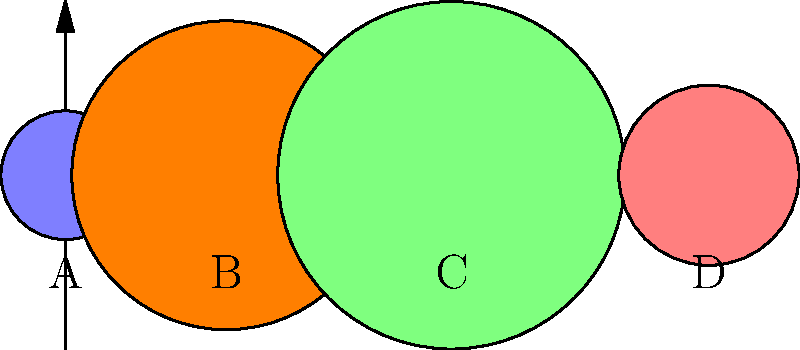In the context of leveraging AI to address homelessness, consider the following analogy: Just as planets vary in size, so do the challenges faced by different homeless populations. The diagram shows four planets (A, B, C, and D) represented by circles. If these planets represent Earth, Jupiter, Saturn, and Mars respectively, which planet is incorrectly sized relative to Earth? To answer this question, we need to compare the relative sizes of the planets to Earth:

1. Planet A represents Earth, our reference point.

2. Planet B represents Jupiter:
   - Jupiter's actual diameter is about 11.2 times that of Earth.
   - In the diagram, B's diameter is 2.4 times that of A (4.8 / 2 = 2.4).
   - This is incorrect, as Jupiter should be much larger relative to Earth.

3. Planet C represents Saturn:
   - Saturn's actual diameter is about 9.4 times that of Earth.
   - In the diagram, C's diameter is 2.7 times that of A (5.4 / 2 = 2.7).
   - This is also incorrect, but not as drastically as Jupiter.

4. Planet D represents Mars:
   - Mars' actual diameter is about 0.53 times that of Earth.
   - In the diagram, D's diameter is 1.4 times that of A (2.8 / 2 = 1.4).
   - This is incorrect, as Mars should be smaller than Earth.

While all planets are not accurately scaled, Jupiter (B) is the most incorrectly sized relative to Earth, being much smaller in the diagram than it should be in reality.

This analogy reminds us that when using AI to address homelessness, we must be aware that the scale and nature of challenges can vary significantly between different populations and regions, just as planets vary in size.
Answer: Jupiter (B) 